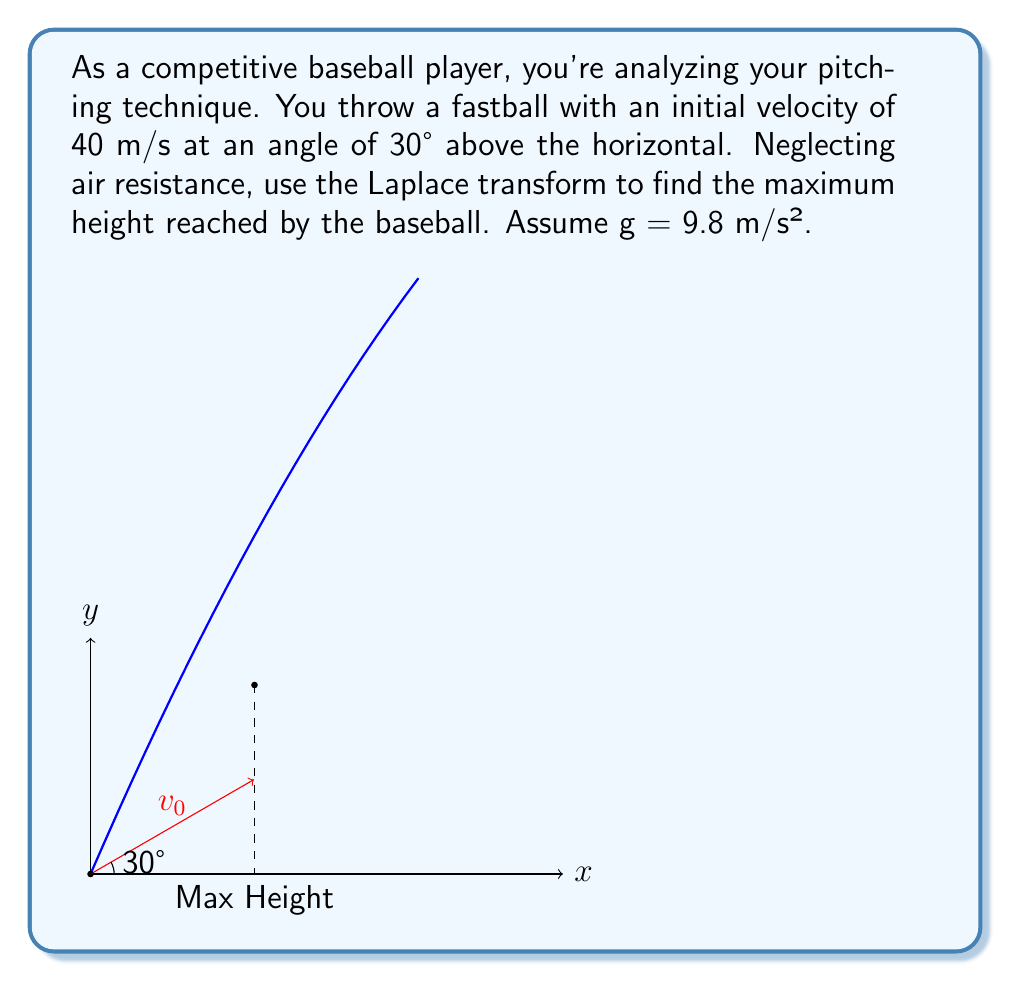What is the answer to this math problem? Let's approach this step-by-step using Laplace transforms:

1) The vertical position of the baseball is given by:
   $$y(t) = v_0 \sin(\theta)t - \frac{1}{2}gt^2$$

2) Taking the Laplace transform of both sides:
   $$\mathcal{L}\{y(t)\} = \mathcal{L}\{v_0 \sin(\theta)t\} - \mathcal{L}\{\frac{1}{2}gt^2\}$$

3) Using Laplace transform properties:
   $$Y(s) = \frac{v_0 \sin(\theta)}{s^2} - \frac{g}{s^3}$$

4) To find the maximum height, we need to find when the velocity is zero:
   $$\mathcal{L}\{\frac{dy}{dt}\} = sY(s) = \frac{v_0 \sin(\theta)}{s} - \frac{g}{s^2}$$

5) Setting this equal to zero and solving for $s$:
   $$\frac{v_0 \sin(\theta)}{s} - \frac{g}{s^2} = 0$$
   $$v_0 \sin(\theta)s = g$$
   $$s = \frac{g}{v_0 \sin(\theta)}$$

6) This $s$ corresponds to the time of maximum height. To find this time, we take the inverse Laplace transform:
   $$t_{max} = \mathcal{L}^{-1}\{\frac{1}{s}\} = \frac{v_0 \sin(\theta)}{g}$$

7) Substituting the given values:
   $$t_{max} = \frac{40 \sin(30°)}{9.8} = 2.04 \text{ seconds}$$

8) Now, we can find the maximum height by substituting this time into the original equation:
   $$y_{max} = v_0 \sin(\theta)t_{max} - \frac{1}{2}gt_{max}^2$$
   $$y_{max} = 40 \sin(30°)(2.04) - \frac{1}{2}(9.8)(2.04)^2$$
   $$y_{max} = 40.8 - 20.4 = 20.4 \text{ meters}$$
Answer: 20.4 meters 